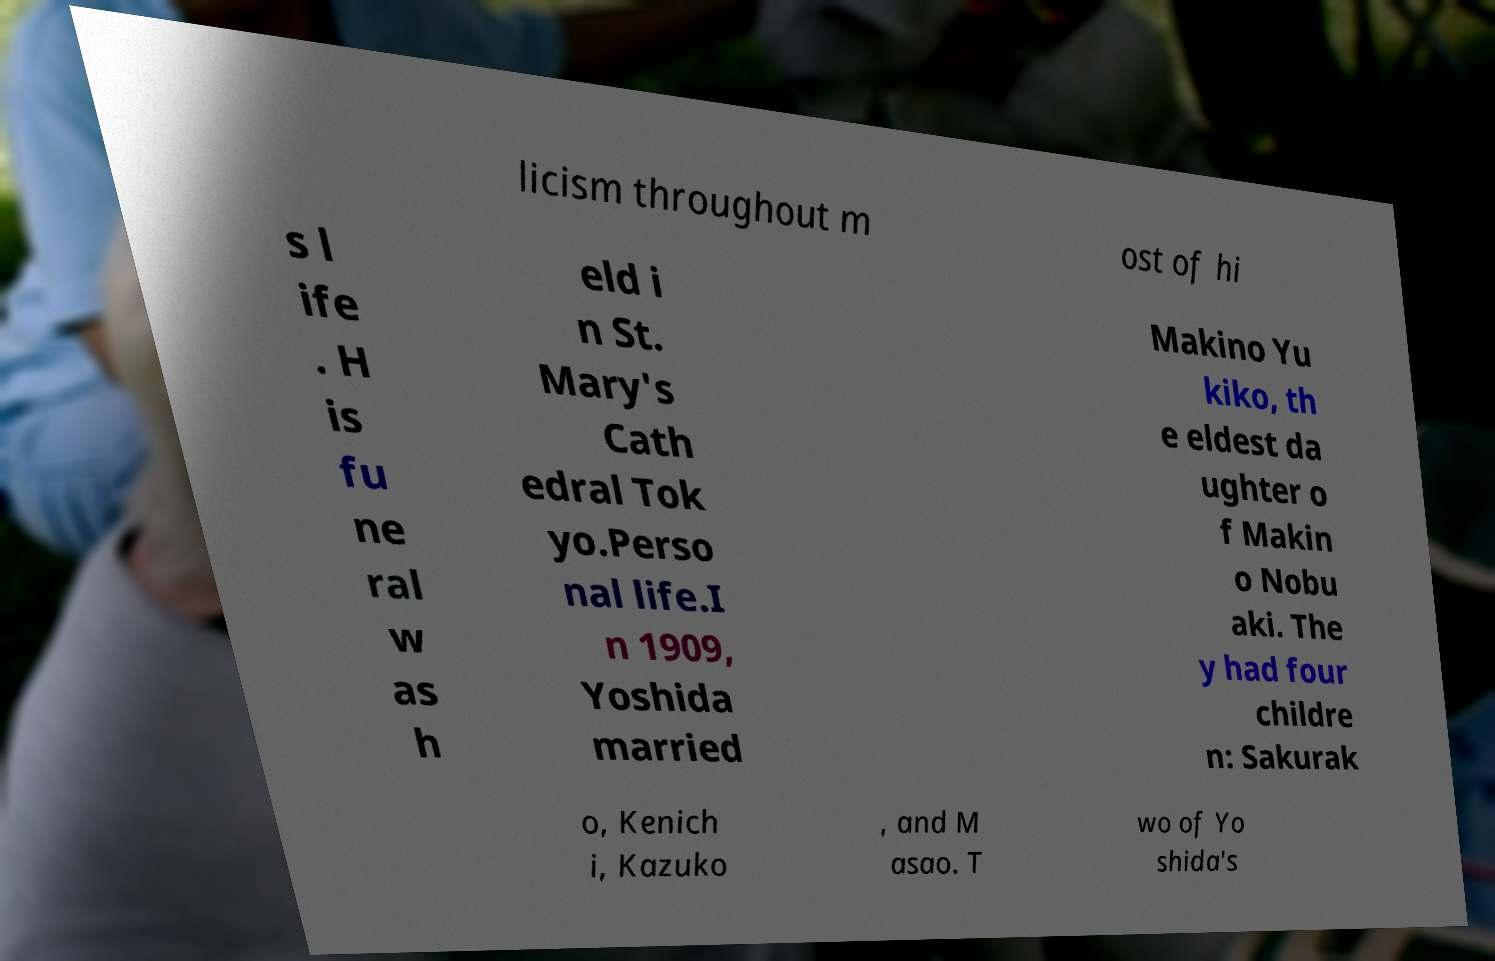Please identify and transcribe the text found in this image. licism throughout m ost of hi s l ife . H is fu ne ral w as h eld i n St. Mary's Cath edral Tok yo.Perso nal life.I n 1909, Yoshida married Makino Yu kiko, th e eldest da ughter o f Makin o Nobu aki. The y had four childre n: Sakurak o, Kenich i, Kazuko , and M asao. T wo of Yo shida's 